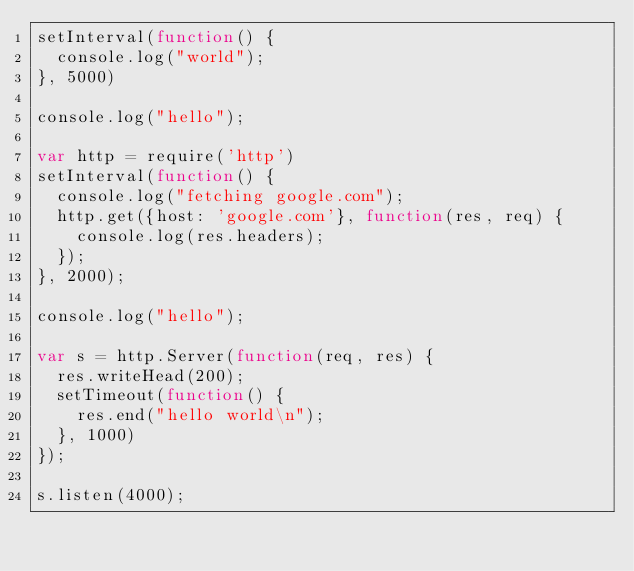Convert code to text. <code><loc_0><loc_0><loc_500><loc_500><_JavaScript_>setInterval(function() {
  console.log("world");
}, 5000)

console.log("hello");

var http = require('http')
setInterval(function() {
  console.log("fetching google.com");
  http.get({host: 'google.com'}, function(res, req) {
    console.log(res.headers);
  });
}, 2000);

console.log("hello");

var s = http.Server(function(req, res) {
  res.writeHead(200);
  setTimeout(function() {
    res.end("hello world\n");
  }, 1000)
});

s.listen(4000);</code> 